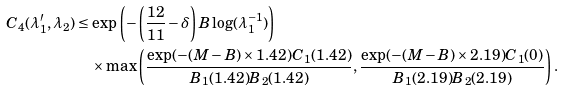Convert formula to latex. <formula><loc_0><loc_0><loc_500><loc_500>C _ { 4 } ( \lambda _ { 1 } ^ { \prime } , \lambda _ { 2 } ) & \leq \exp \left ( - \left ( \frac { 1 2 } { 1 1 } - \delta \right ) B \log ( \lambda _ { 1 } ^ { - 1 } ) \right ) \\ & \quad \times \max \left ( \frac { \exp ( - ( M - B ) \times 1 . 4 2 ) C _ { 1 } ( 1 . 4 2 ) } { B _ { 1 } ( 1 . 4 2 ) B _ { 2 } ( 1 . 4 2 ) } , \frac { \exp ( - ( M - B ) \times 2 . 1 9 ) C _ { 1 } ( 0 ) } { B _ { 1 } ( 2 . 1 9 ) B _ { 2 } ( 2 . 1 9 ) } \right ) .</formula> 